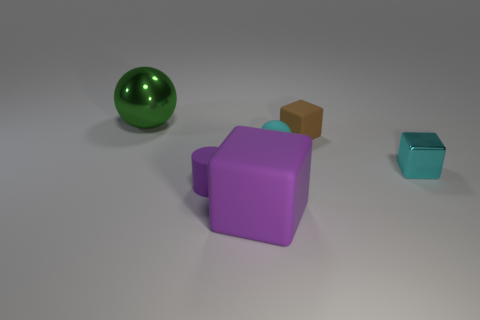Add 2 tiny blue rubber balls. How many objects exist? 8 Subtract all spheres. How many objects are left? 4 Subtract 0 yellow cylinders. How many objects are left? 6 Subtract all gray objects. Subtract all tiny cyan balls. How many objects are left? 5 Add 6 small brown cubes. How many small brown cubes are left? 7 Add 4 large purple rubber objects. How many large purple rubber objects exist? 5 